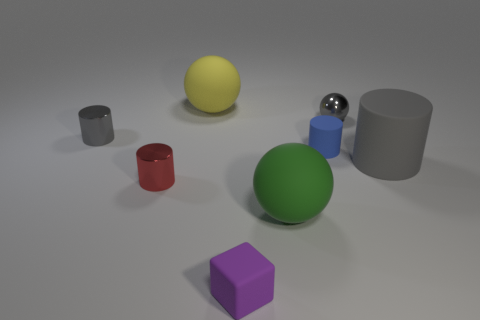What number of rubber objects are on the left side of the ball in front of the gray cylinder that is to the right of the yellow sphere?
Ensure brevity in your answer.  2. Is the material of the gray object to the left of the big green matte sphere the same as the small cylinder that is to the right of the block?
Offer a very short reply. No. There is a tiny cylinder that is the same color as the big matte cylinder; what is it made of?
Ensure brevity in your answer.  Metal. How many big purple things have the same shape as the yellow matte thing?
Ensure brevity in your answer.  0. Is the number of matte blocks behind the shiny ball greater than the number of red cylinders?
Your answer should be compact. No. There is a matte thing that is behind the gray metallic thing that is on the right side of the gray cylinder that is to the left of the small purple matte cube; what shape is it?
Ensure brevity in your answer.  Sphere. Is the shape of the tiny metal object left of the small red cylinder the same as the big matte thing in front of the red metal object?
Offer a very short reply. No. Is there any other thing that is the same size as the red metal object?
Ensure brevity in your answer.  Yes. What number of cylinders are metal objects or tiny gray matte objects?
Your response must be concise. 2. Is the tiny blue cylinder made of the same material as the cube?
Your response must be concise. Yes. 